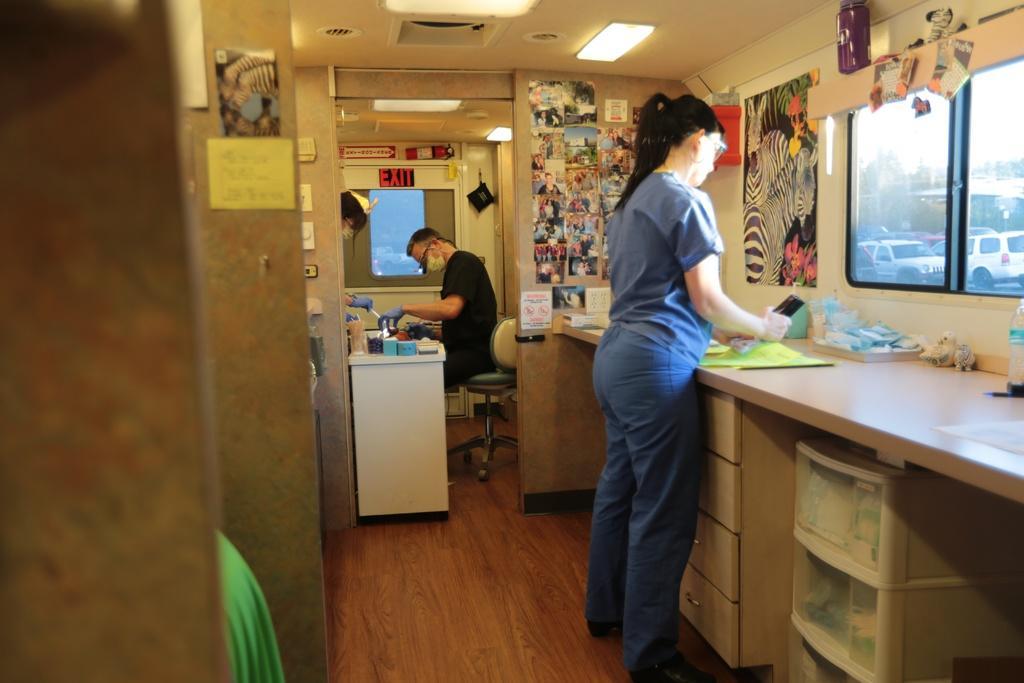In one or two sentences, can you explain what this image depicts? This is a picture inside the room. There is a person standing at the desk and there is another person sitting at the table. At the right there is a window and at the top there are lights and there are photos on the wall, there are bottles, cloth on the desk. 